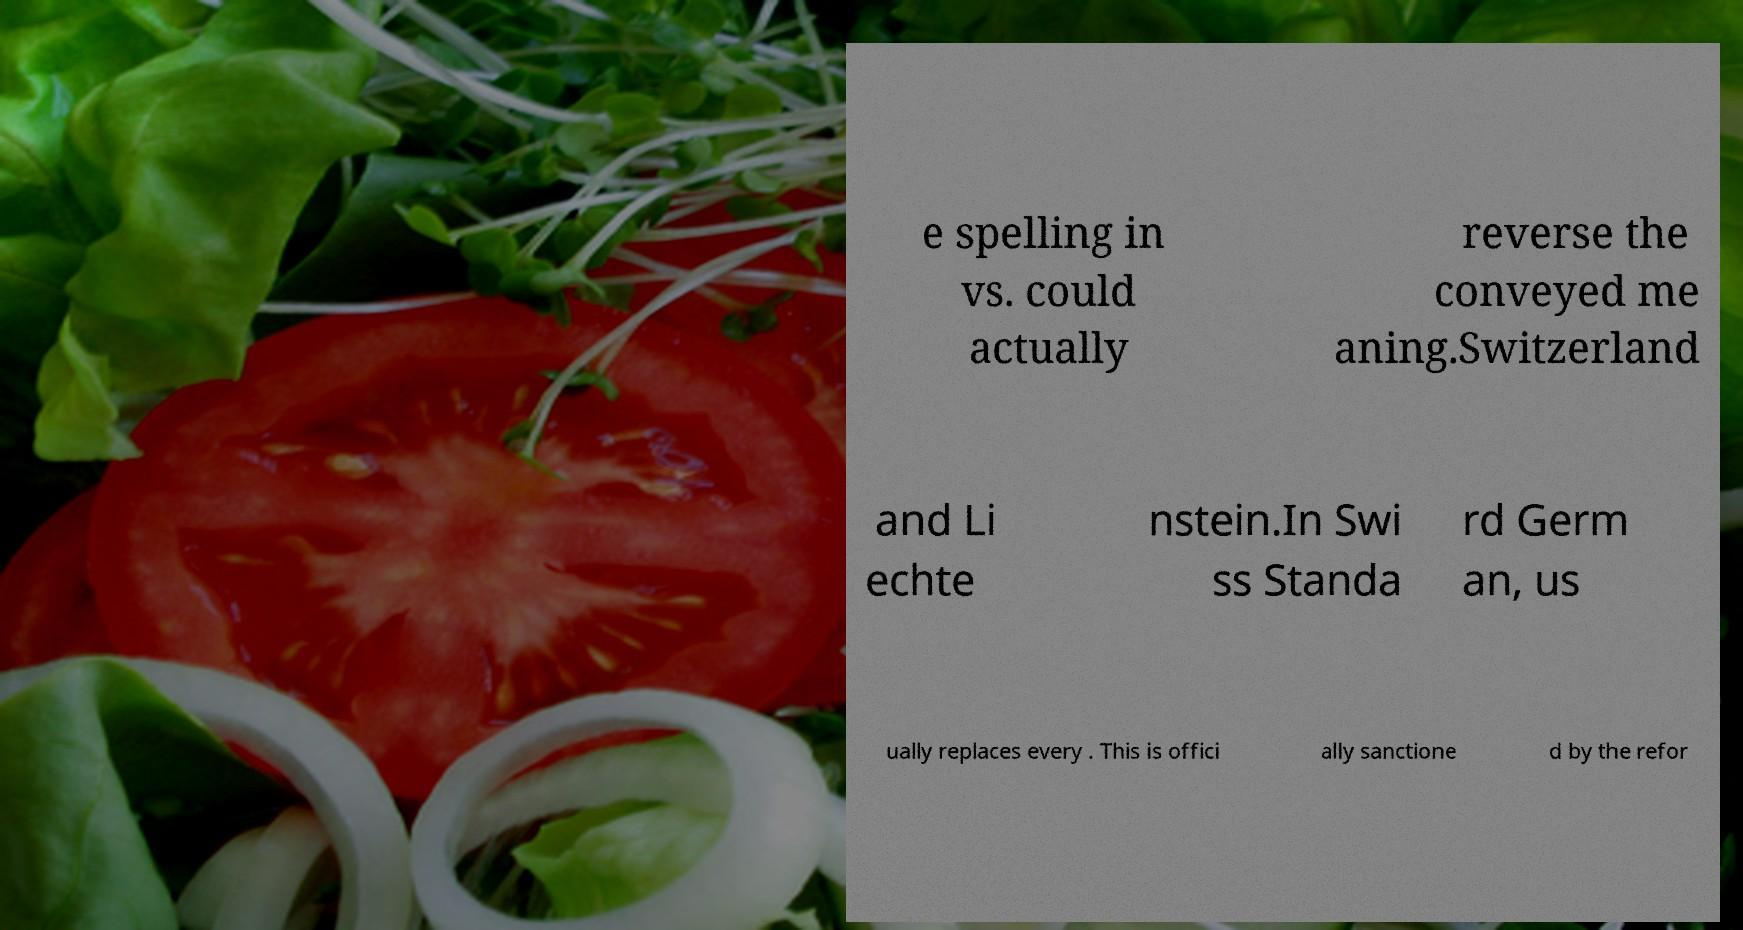Could you assist in decoding the text presented in this image and type it out clearly? e spelling in vs. could actually reverse the conveyed me aning.Switzerland and Li echte nstein.In Swi ss Standa rd Germ an, us ually replaces every . This is offici ally sanctione d by the refor 